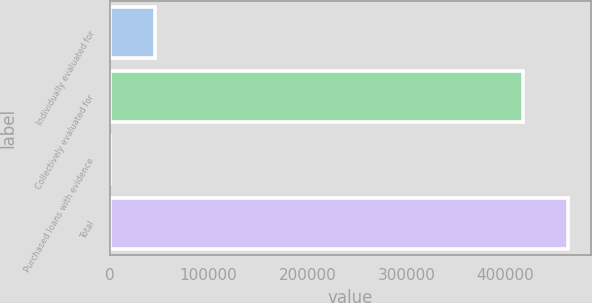<chart> <loc_0><loc_0><loc_500><loc_500><bar_chart><fcel>Individually evaluated for<fcel>Collectively evaluated for<fcel>Purchased loans with evidence<fcel>Total<nl><fcel>45493.4<fcel>417295<fcel>73<fcel>462715<nl></chart> 